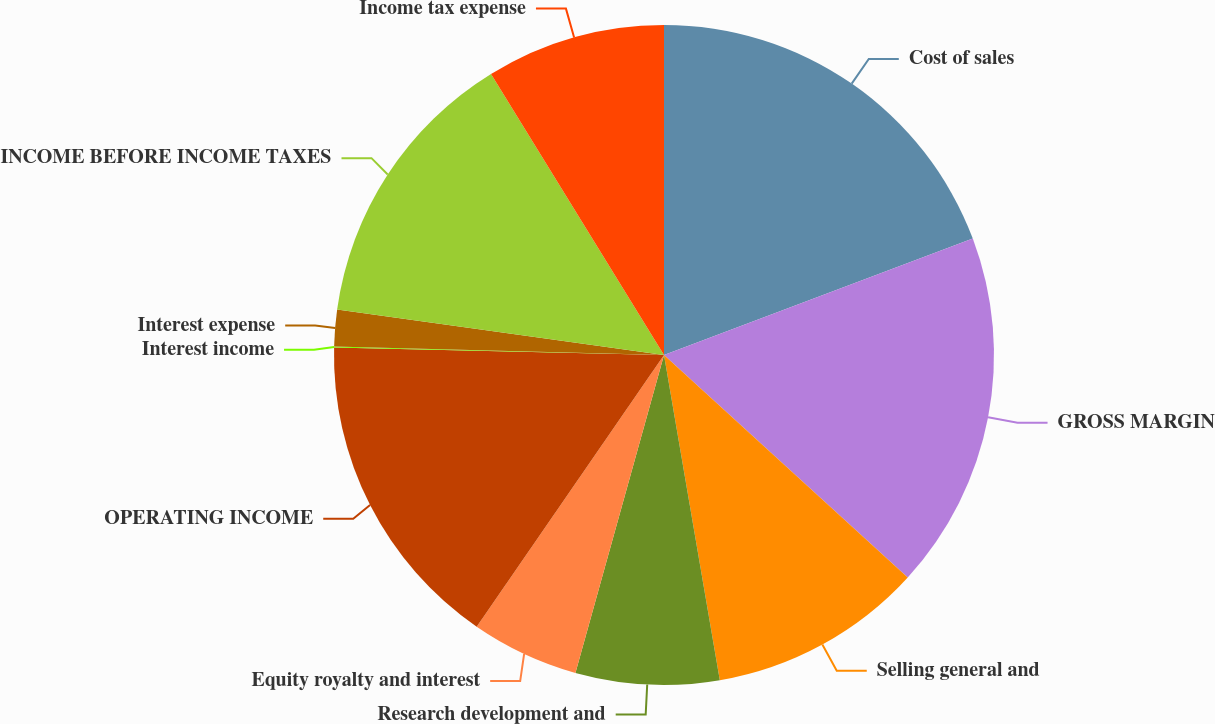<chart> <loc_0><loc_0><loc_500><loc_500><pie_chart><fcel>Cost of sales<fcel>GROSS MARGIN<fcel>Selling general and<fcel>Research development and<fcel>Equity royalty and interest<fcel>OPERATING INCOME<fcel>Interest income<fcel>Interest expense<fcel>INCOME BEFORE INCOME TAXES<fcel>Income tax expense<nl><fcel>19.26%<fcel>17.51%<fcel>10.52%<fcel>7.03%<fcel>5.28%<fcel>15.76%<fcel>0.04%<fcel>1.79%<fcel>14.02%<fcel>8.78%<nl></chart> 